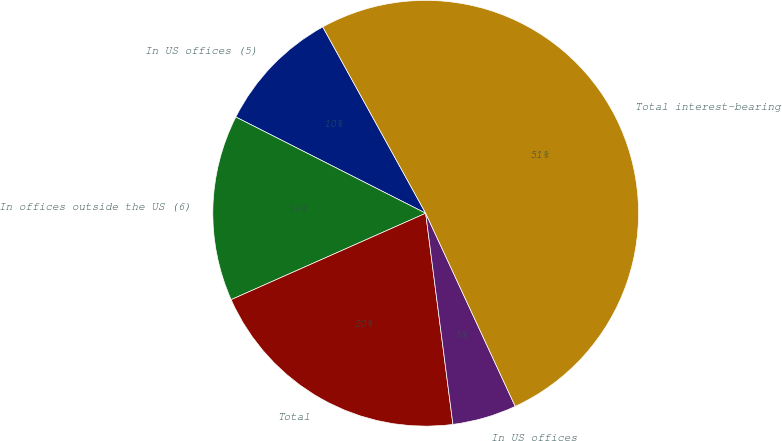<chart> <loc_0><loc_0><loc_500><loc_500><pie_chart><fcel>In US offices (5)<fcel>In offices outside the US (6)<fcel>Total<fcel>In US offices<fcel>Total interest-bearing<nl><fcel>9.5%<fcel>14.12%<fcel>20.39%<fcel>4.87%<fcel>51.12%<nl></chart> 